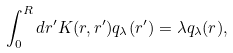<formula> <loc_0><loc_0><loc_500><loc_500>\int _ { 0 } ^ { R } d r ^ { \prime } K ( r , r ^ { \prime } ) q _ { \lambda } ( r ^ { \prime } ) = \lambda q _ { \lambda } ( r ) ,</formula> 